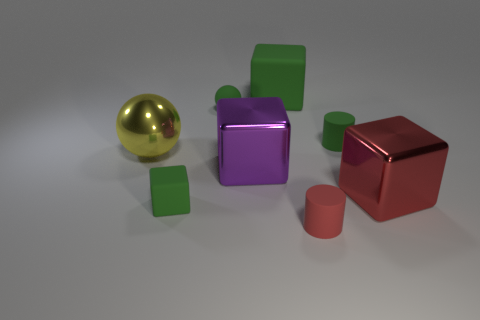Add 1 large yellow metallic objects. How many objects exist? 9 Subtract all cylinders. How many objects are left? 6 Add 4 small matte blocks. How many small matte blocks exist? 5 Subtract 1 red blocks. How many objects are left? 7 Subtract all blue matte cubes. Subtract all big yellow metal objects. How many objects are left? 7 Add 2 metallic blocks. How many metallic blocks are left? 4 